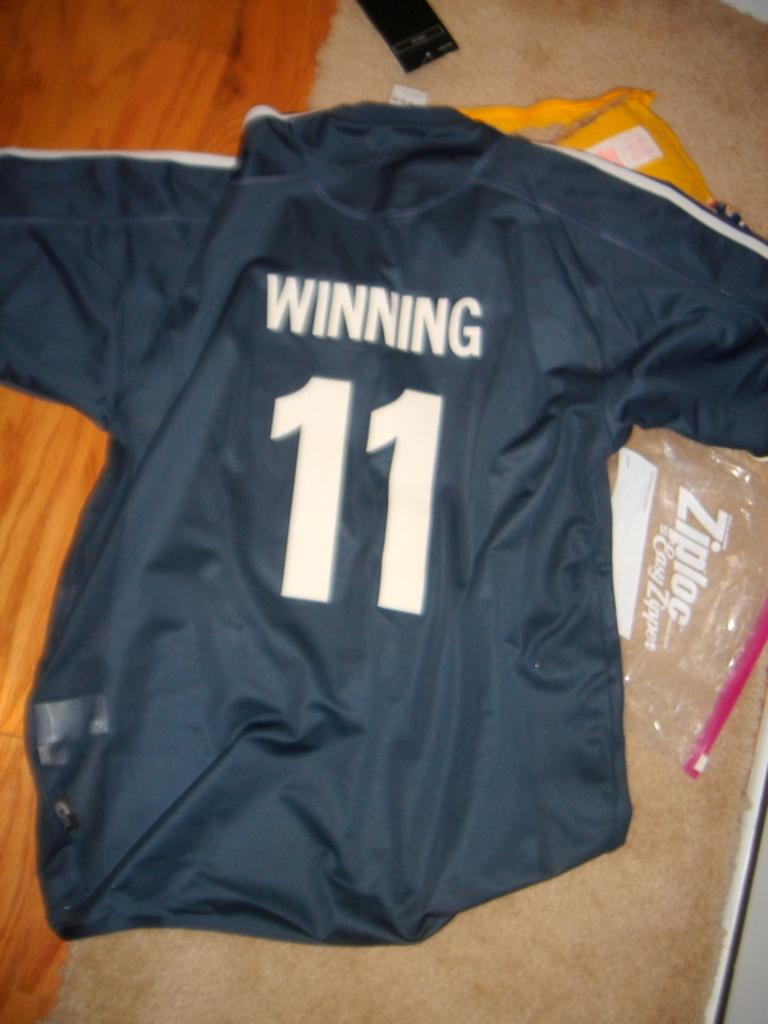<image>
Offer a succinct explanation of the picture presented. A blue jersey that says winning and has the number 11 on it. 